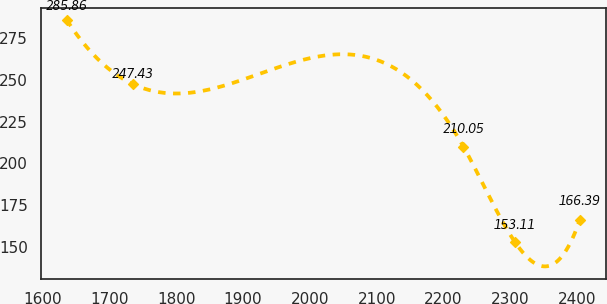<chart> <loc_0><loc_0><loc_500><loc_500><line_chart><ecel><fcel>Unnamed: 1<nl><fcel>1636.17<fcel>285.86<nl><fcel>1735.23<fcel>247.43<nl><fcel>2229.69<fcel>210.05<nl><fcel>2306.47<fcel>153.11<nl><fcel>2404<fcel>166.39<nl></chart> 